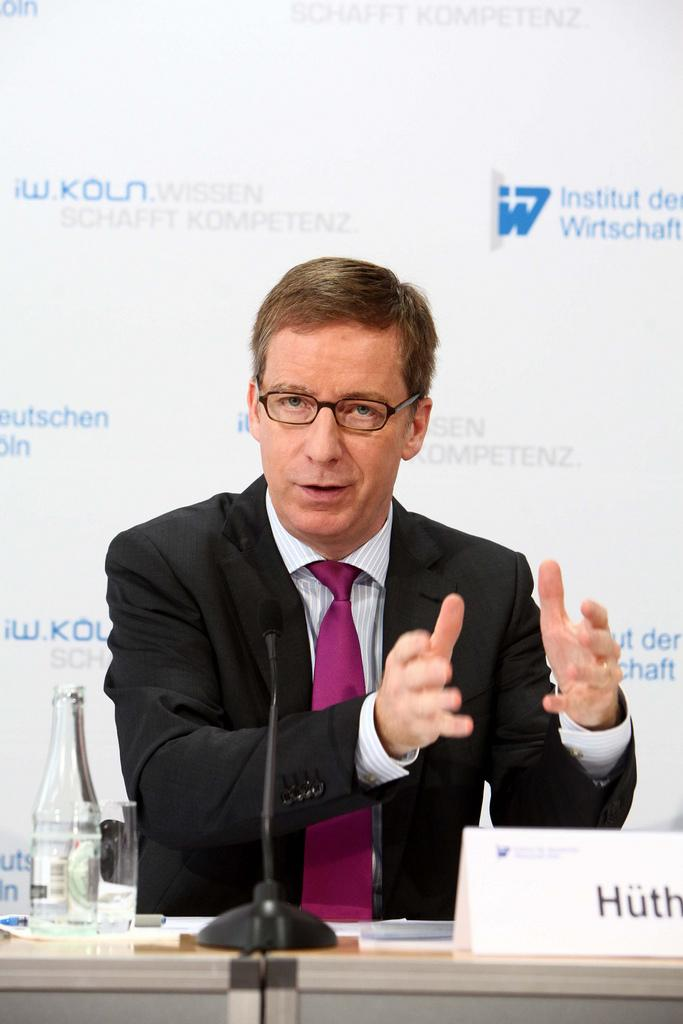What is the man in the image doing? The man is sitting in a chair and explaining something. What objects can be seen on the table in the image? There is a name board, a microphone, a bottle, a glass, a paper, and a pen on the table in the image. What is the purpose of the microphone on the table? The microphone on the table is likely used for amplifying the man's voice during his explanation. What is the hoarding in the background of the image advertising? The provided facts do not specify what the hoarding is advertising. How many mice are hiding under the table in the image? There are no mice present in the image. Are there any cats visible in the image? There are no cats present in the image. 